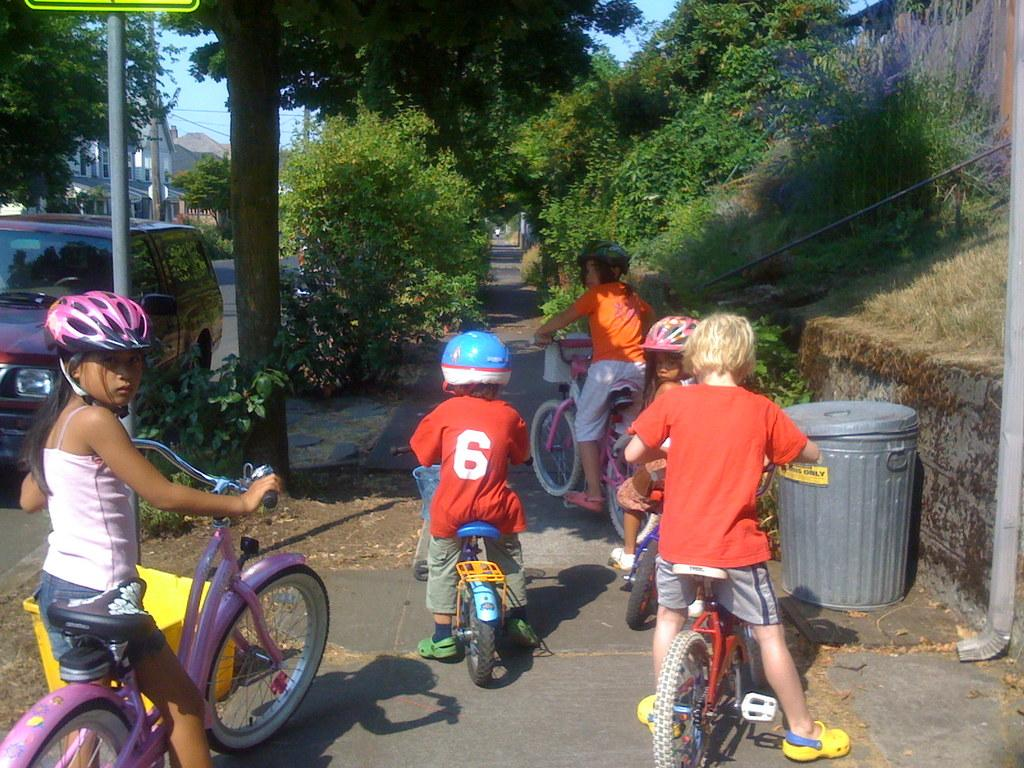What are the children in the image doing? The children in the image are riding bicycles. Where are the children riding their bicycles? They are on a road. What can be seen in the background of the image? There is a dustbin, a car, a board, a tree, a building, and the sky visible in the background. What type of stove can be seen in the image? There is no stove present in the image. What color is the sheet that the children are using to ride their bicycles? The children are not using a sheet to ride their bicycles; they are riding on a road. 